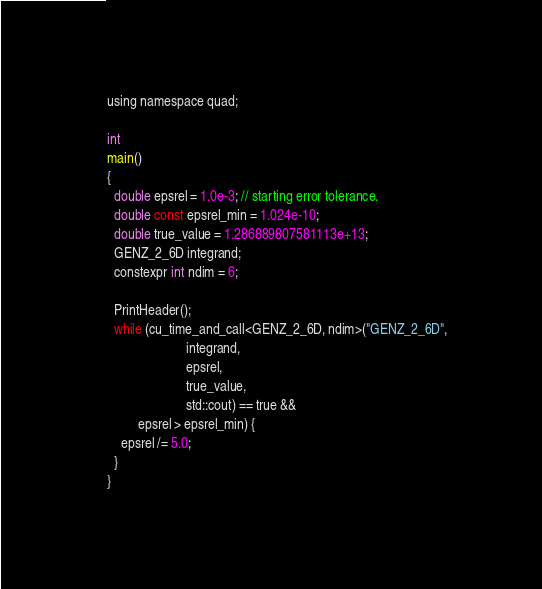Convert code to text. <code><loc_0><loc_0><loc_500><loc_500><_Cuda_>using namespace quad;

int
main()
{
  double epsrel = 1.0e-3; // starting error tolerance.
  double const epsrel_min = 1.024e-10;
  double true_value = 1.286889807581113e+13;
  GENZ_2_6D integrand;
  constexpr int ndim = 6;
  
  PrintHeader();
  while (cu_time_and_call<GENZ_2_6D, ndim>("GENZ_2_6D",
                       integrand,
                       epsrel,
                       true_value,
                       std::cout) == true &&
         epsrel > epsrel_min) {
    epsrel /= 5.0;
  }
}
</code> 